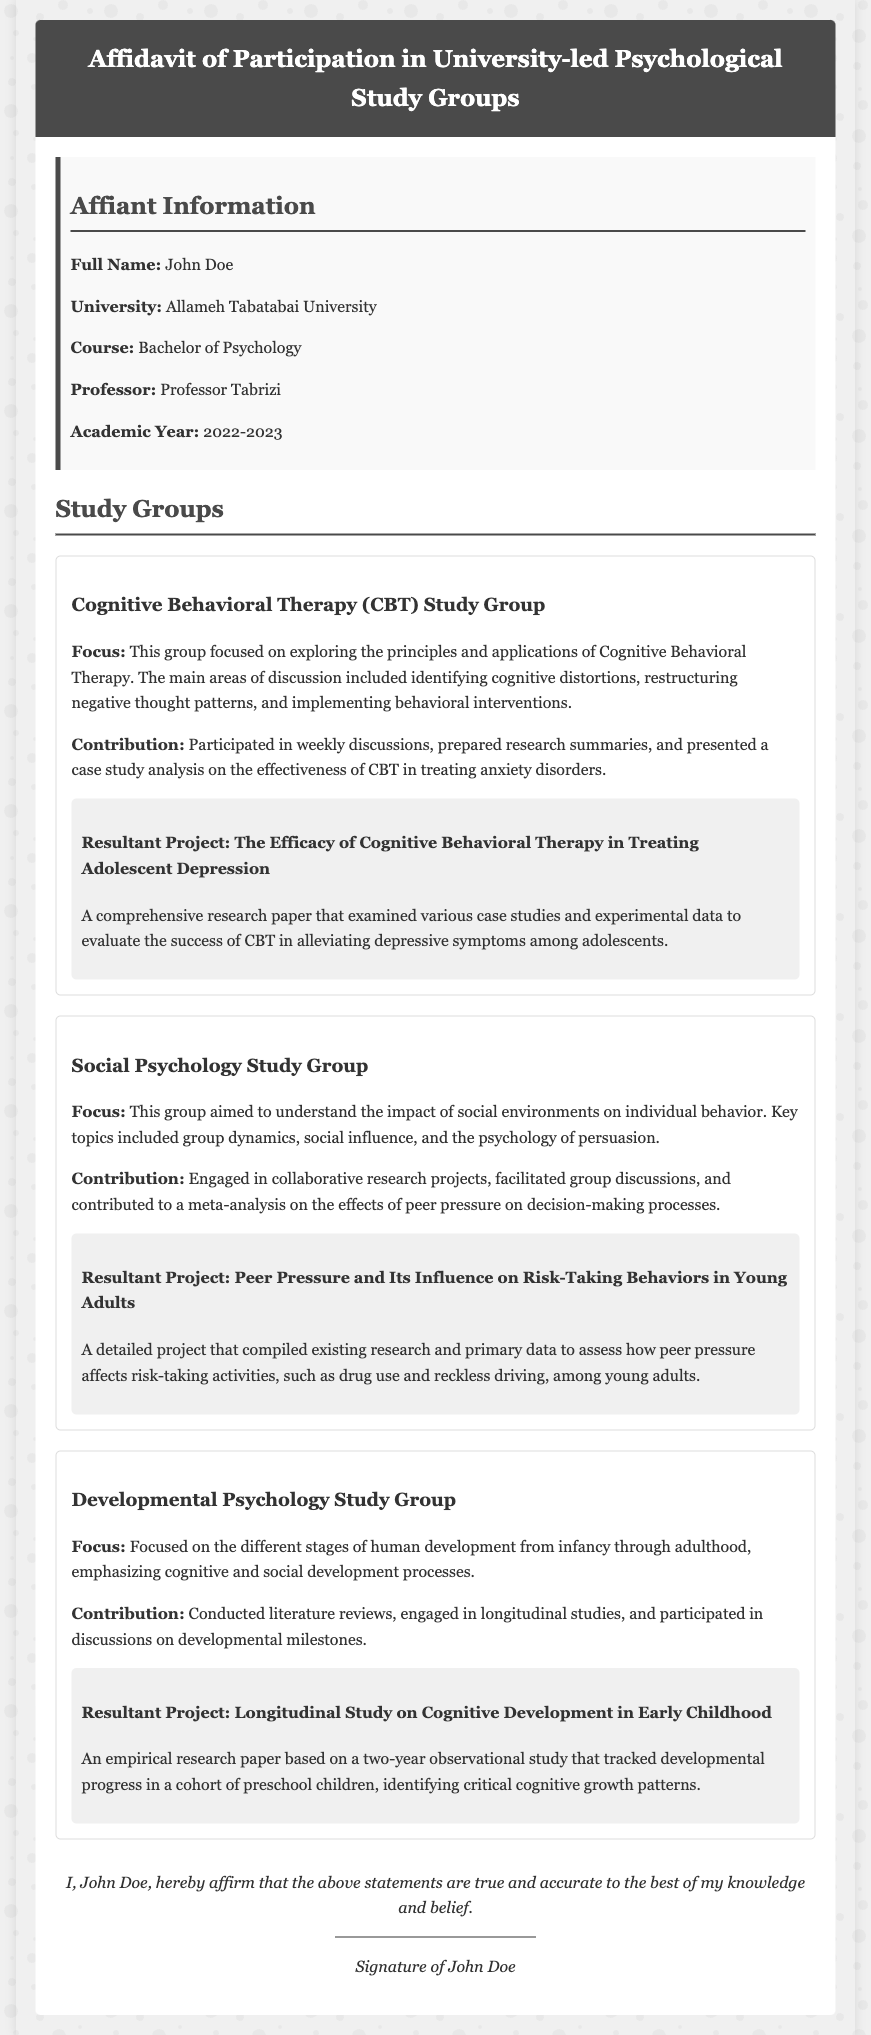What is the name of the affiant? The affiant is who provides the affidavit, which is stated as "John Doe."
Answer: John Doe Which university is mentioned in the document? The affidavit mentions the affiant's university, which is clearly stated as "Allameh Tabatabai University."
Answer: Allameh Tabatabai University What was the focus of the Cognitive Behavioral Therapy Study Group? The focus is specified in the document, indicating exploration of "the principles and applications of Cognitive Behavioral Therapy."
Answer: The principles and applications of Cognitive Behavioral Therapy How many study groups participated in the affidavit? The document lists a total of three study groups, which can be counted in the provided sections.
Answer: Three What was the title of the resultant project from the Social Psychology Study Group? The title of the resultant project is explicitly stated as "Peer Pressure and Its Influence on Risk-Taking Behaviors in Young Adults."
Answer: Peer Pressure and Its Influence on Risk-Taking Behaviors in Young Adults What type of study was conducted in the Developmental Psychology Study Group? The type of study conducted, according to the text, was a "longitudinal study."
Answer: Longitudinal study In which academic year did John Doe participate in the study groups? The academic year is mentioned in the affiant's information, specifically citing "2022-2023."
Answer: 2022-2023 What is the main contribution listed under the Cognitive Behavioral Therapy Study Group? The main contribution is highlighted in the document as "Participated in weekly discussions, prepared research summaries, and presented a case study analysis."
Answer: Participated in weekly discussions, prepared research summaries, and presented a case study analysis What is the signature element in this affidavit? The document concludes with a statement confirming the affiant's agreement and provides a space for the signature, indicating the declaration of accuracy.
Answer: Signature of John Doe 